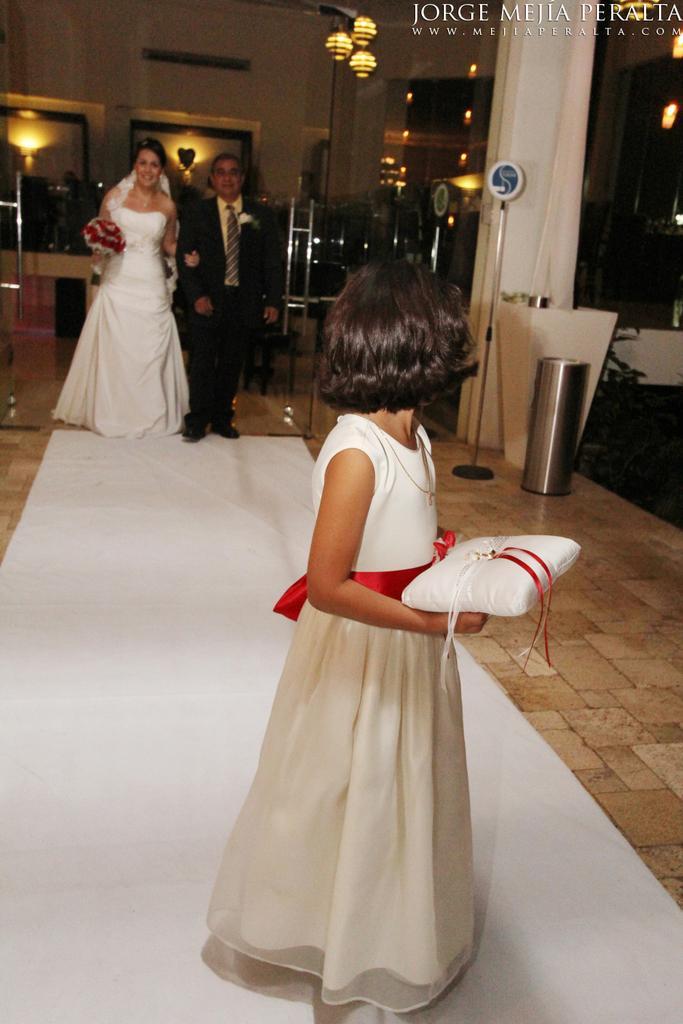How would you summarize this image in a sentence or two? This is an inside view. In the foreground, I can see a girl wearing white color frock and holding a white color object in the hands and looking at the backwards. She is standing on the white color mat. In the background, I can see a man and a woman standing and smiling. The woman is wearing a white color frock and holding some flowers in the hand. The man is wearing black color suit. On the right side, I can see a pillar and a dustbin which is placed on the floor. At the top there are some lights. In the background there is a wall. 